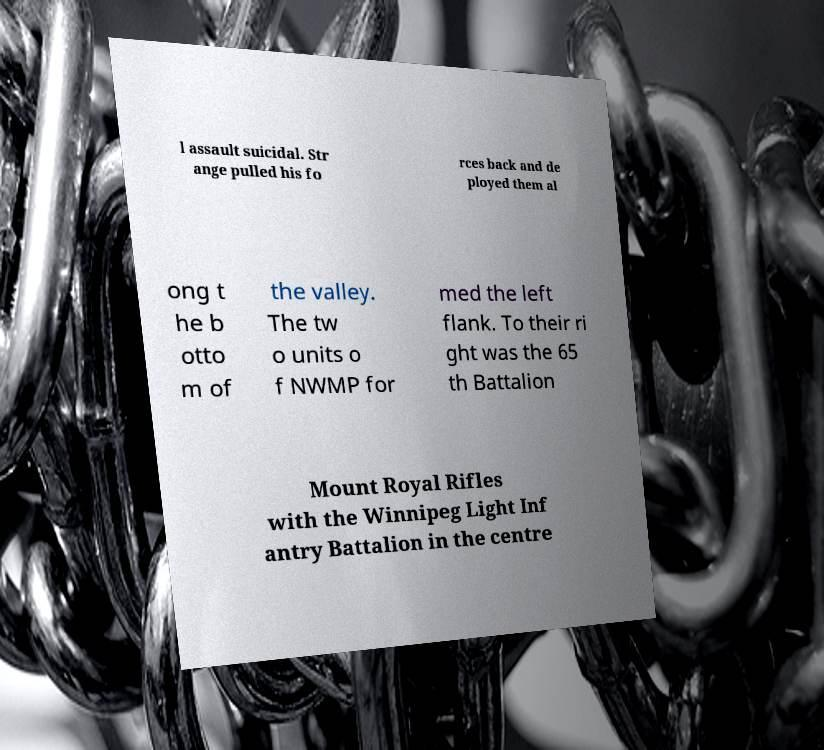Can you accurately transcribe the text from the provided image for me? l assault suicidal. Str ange pulled his fo rces back and de ployed them al ong t he b otto m of the valley. The tw o units o f NWMP for med the left flank. To their ri ght was the 65 th Battalion Mount Royal Rifles with the Winnipeg Light Inf antry Battalion in the centre 